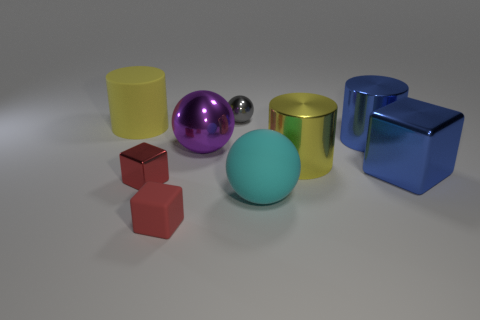Subtract all large metallic cylinders. How many cylinders are left? 1 Subtract all cyan cylinders. How many red blocks are left? 2 Add 1 tiny red matte things. How many objects exist? 10 Subtract all cyan spheres. How many spheres are left? 2 Subtract 2 spheres. How many spheres are left? 1 Subtract all blocks. How many objects are left? 6 Subtract all yellow cylinders. Subtract all green cubes. How many cylinders are left? 1 Subtract all large cyan matte objects. Subtract all large rubber balls. How many objects are left? 7 Add 6 large rubber spheres. How many large rubber spheres are left? 7 Add 7 big blue shiny cylinders. How many big blue shiny cylinders exist? 8 